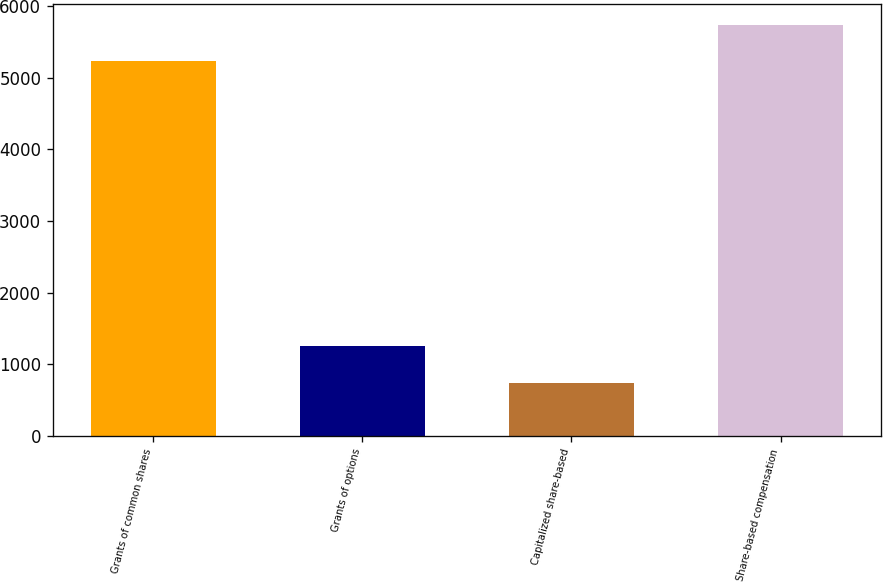Convert chart to OTSL. <chart><loc_0><loc_0><loc_500><loc_500><bar_chart><fcel>Grants of common shares<fcel>Grants of options<fcel>Capitalized share-based<fcel>Share-based compensation<nl><fcel>5232<fcel>1255<fcel>745<fcel>5742<nl></chart> 